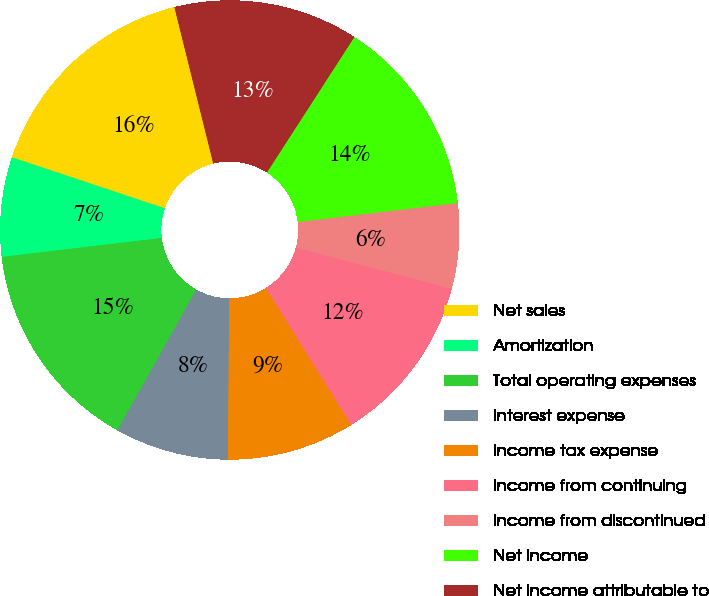Convert chart. <chart><loc_0><loc_0><loc_500><loc_500><pie_chart><fcel>Net sales<fcel>Amortization<fcel>Total operating expenses<fcel>Interest expense<fcel>Income tax expense<fcel>Income from continuing<fcel>Income from discontinued<fcel>Net income<fcel>Net income attributable to<nl><fcel>16.0%<fcel>7.0%<fcel>15.0%<fcel>8.0%<fcel>9.0%<fcel>12.0%<fcel>6.0%<fcel>14.0%<fcel>13.0%<nl></chart> 